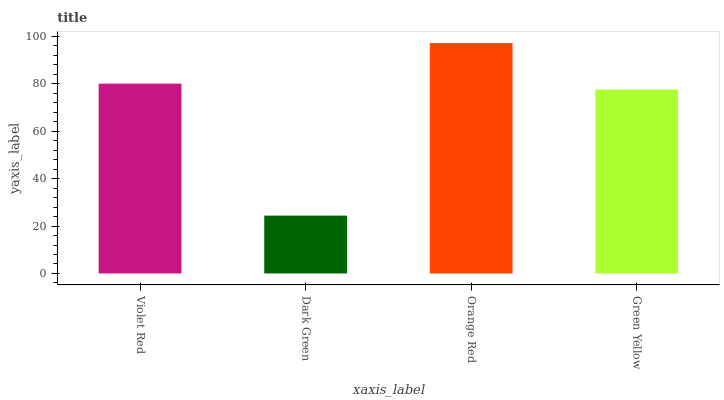Is Dark Green the minimum?
Answer yes or no. Yes. Is Orange Red the maximum?
Answer yes or no. Yes. Is Orange Red the minimum?
Answer yes or no. No. Is Dark Green the maximum?
Answer yes or no. No. Is Orange Red greater than Dark Green?
Answer yes or no. Yes. Is Dark Green less than Orange Red?
Answer yes or no. Yes. Is Dark Green greater than Orange Red?
Answer yes or no. No. Is Orange Red less than Dark Green?
Answer yes or no. No. Is Violet Red the high median?
Answer yes or no. Yes. Is Green Yellow the low median?
Answer yes or no. Yes. Is Dark Green the high median?
Answer yes or no. No. Is Orange Red the low median?
Answer yes or no. No. 